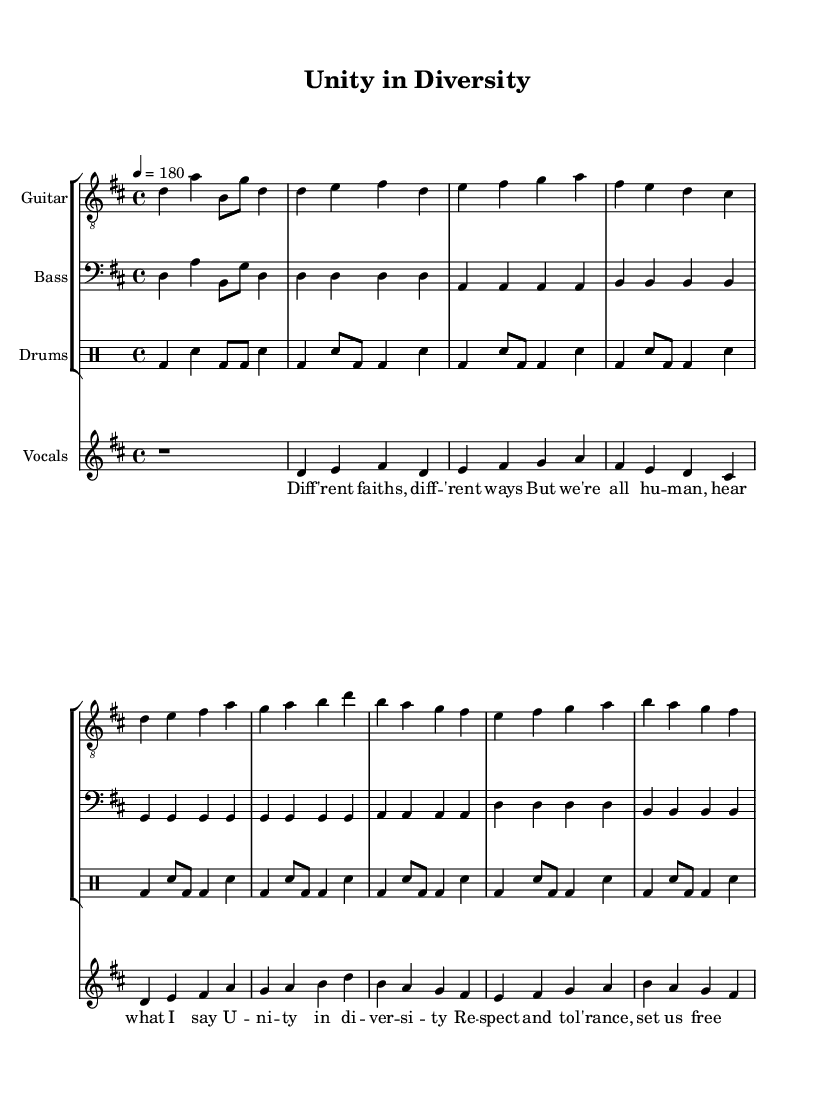What is the key signature of this music? The key signature is indicated by the sharp signs at the beginning of the staff. In this case, there is a single sharp, which corresponds to the key of D major.
Answer: D major What is the time signature of this piece? The time signature indicates how many beats are in each measure and what note value gets one beat. In this music sheet, the time signature is shown as 4/4, meaning there are four beats per measure and the quarter note gets one beat.
Answer: 4/4 What is the tempo marking in this music? The tempo is indicated at the beginning of the score. Here it is marked as "4 = 180," which means that the metronome should be set to 180 beats per minute, and each beat corresponds to a quarter note.
Answer: 180 How many measures are there in the chorus? By counting the measures specifically in the section labeled as the chorus, we can see that there are four measures present.
Answer: 4 What is the main theme conveyed through the lyrics? The lyrics emphasize unity, respect, and tolerance among different faiths, suggesting a message of interfaith dialogue and acceptance. This theme aligns with socially conscious punk rock.
Answer: Unity in diversity What instrument plays the intro? The intro section is played by the guitar, as indicated in the score under the staff labeled "Guitar."
Answer: Guitar How does the bass line relate to the vocal melody in the verse? The bass line primarily consists of root notes that support the harmonic framework of the vocal melody. It follows the same chord changes as the vocals but played in a lower register, which enhances the overall sound without overshadowing the vocal line.
Answer: Supports harmony 